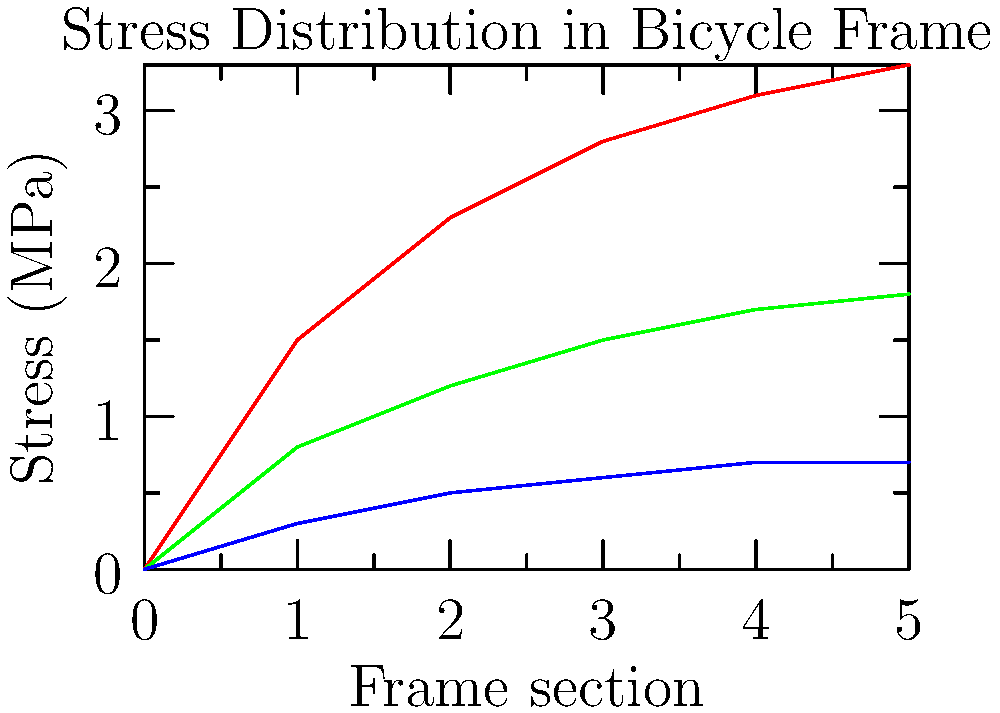Based on the color-coded stress map of a bicycle frame under different riding conditions, which riding condition typically results in the highest overall stress on the frame, and approximately how much higher is the maximum stress compared to the lowest stress condition at the same frame section? To answer this question, let's analyze the stress distribution graph step-by-step:

1. The graph shows stress distribution along different sections of a bicycle frame under three riding conditions: Uphill (red), Flat (green), and Downhill (blue).

2. Observe the position of each line on the graph:
   - The red line (Uphill) is consistently the highest.
   - The green line (Flat) is in the middle.
   - The blue line (Downhill) is the lowest.

3. This indicates that uphill riding typically results in the highest overall stress on the frame.

4. To compare the maximum stress difference:
   - At the rightmost point of the graph (frame section 5):
     * Uphill (red) stress is approximately 3.3 MPa
     * Downhill (blue) stress is approximately 0.7 MPa

5. Calculate the difference:
   $$ \text{Difference} = 3.3 \text{ MPa} - 0.7 \text{ MPa} = 2.6 \text{ MPa} $$

6. To express this as a factor:
   $$ \text{Factor} = \frac{3.3 \text{ MPa}}{0.7 \text{ MPa}} \approx 4.7 $$

Therefore, the uphill riding condition results in the highest overall stress, with the maximum stress being approximately 4.7 times higher than the lowest stress condition (downhill) at the same frame section.
Answer: Uphill; 4.7 times higher 